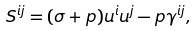Convert formula to latex. <formula><loc_0><loc_0><loc_500><loc_500>S ^ { i j } = ( \sigma + p ) u ^ { i } u ^ { j } - p \gamma ^ { i j } ,</formula> 